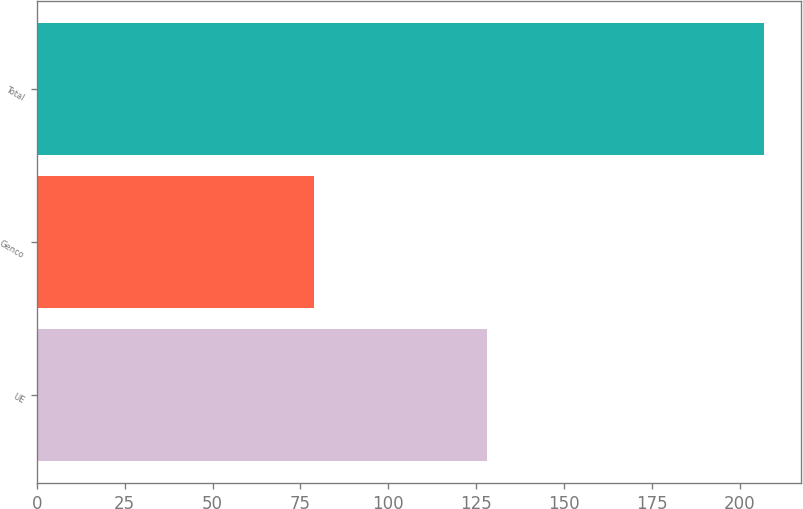Convert chart. <chart><loc_0><loc_0><loc_500><loc_500><bar_chart><fcel>UE<fcel>Genco<fcel>Total<nl><fcel>128<fcel>79<fcel>207<nl></chart> 